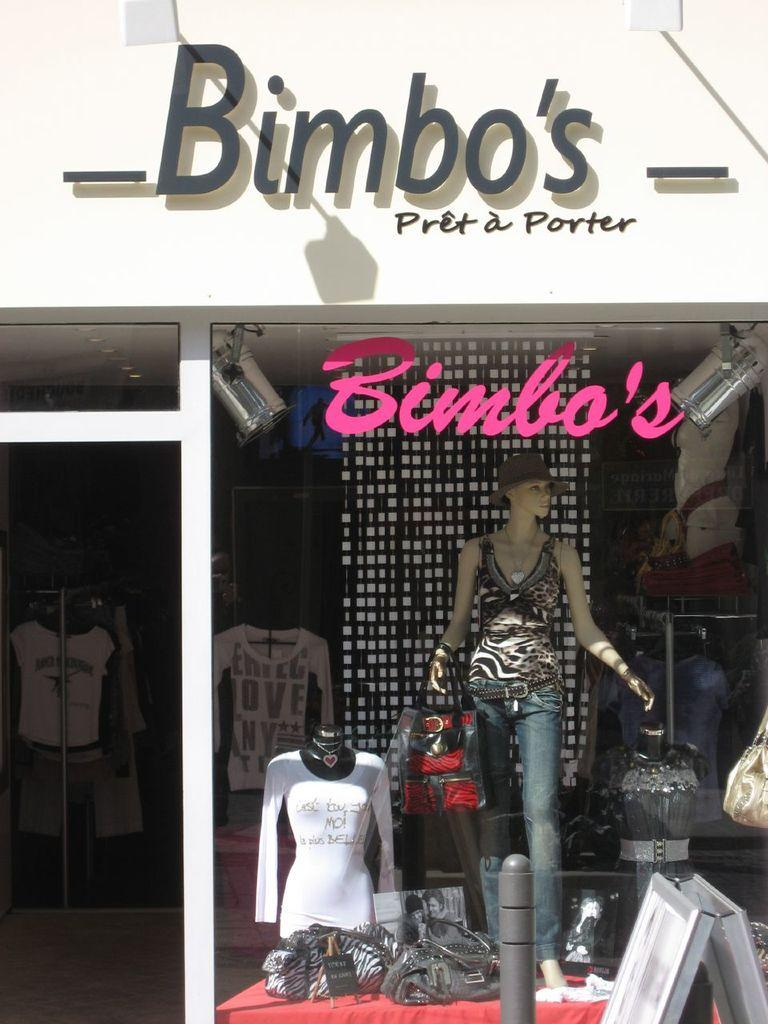Provide a one-sentence caption for the provided image. a boutique store called bimbos pret a porter. 